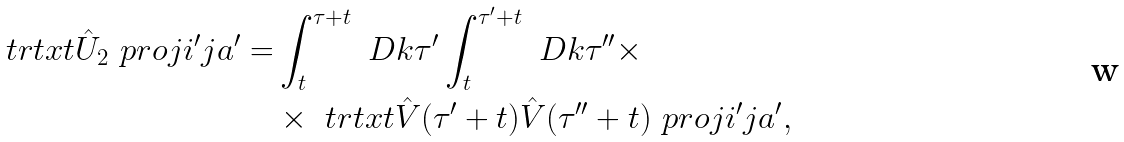<formula> <loc_0><loc_0><loc_500><loc_500>\ t r t x t { \hat { U } _ { 2 } \ p r o j { i ^ { \prime } j } { a ^ { \prime } } } = & \int _ { t } ^ { \tau + t } \ D k \tau ^ { \prime } \int _ { t } ^ { \tau ^ { \prime } + t } \ D k \tau ^ { \prime \prime } \times \\ & \times \ t r t x t { \hat { V } ( \tau ^ { \prime } + t ) \hat { V } ( \tau ^ { \prime \prime } + t ) \ p r o j { i ^ { \prime } j } { a ^ { \prime } } } ,</formula> 